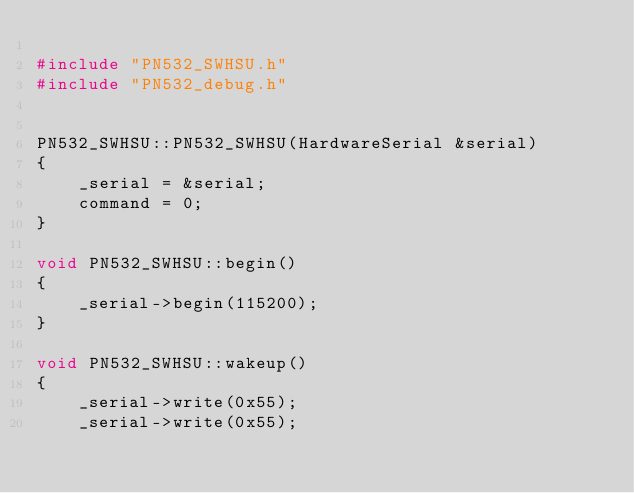Convert code to text. <code><loc_0><loc_0><loc_500><loc_500><_C++_>
#include "PN532_SWHSU.h"
#include "PN532_debug.h"


PN532_SWHSU::PN532_SWHSU(HardwareSerial &serial)
{
    _serial = &serial;
    command = 0;
}

void PN532_SWHSU::begin()
{
    _serial->begin(115200);
}

void PN532_SWHSU::wakeup()
{
    _serial->write(0x55);
    _serial->write(0x55);</code> 